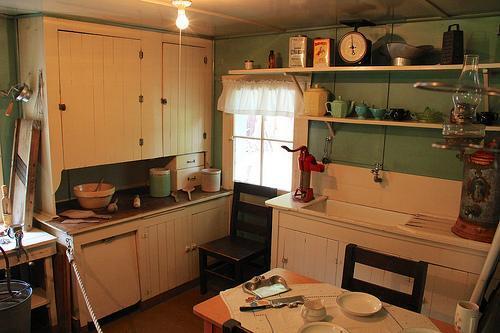How many shelves are there?
Give a very brief answer. 2. How many chairs are pictured?
Give a very brief answer. 2. How many lightbulbs are pictured?
Give a very brief answer. 1. 